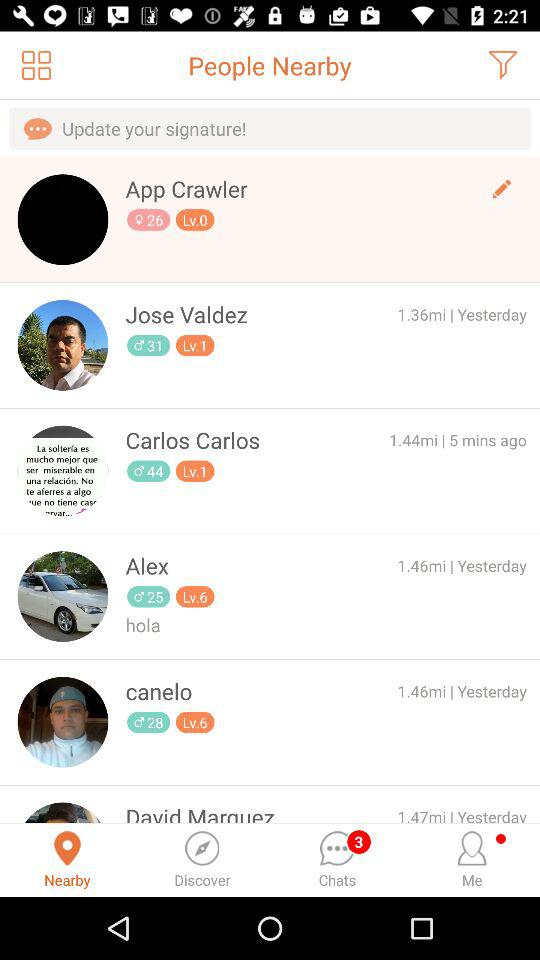Which tab is selected? The selected tab is "Nearby". 